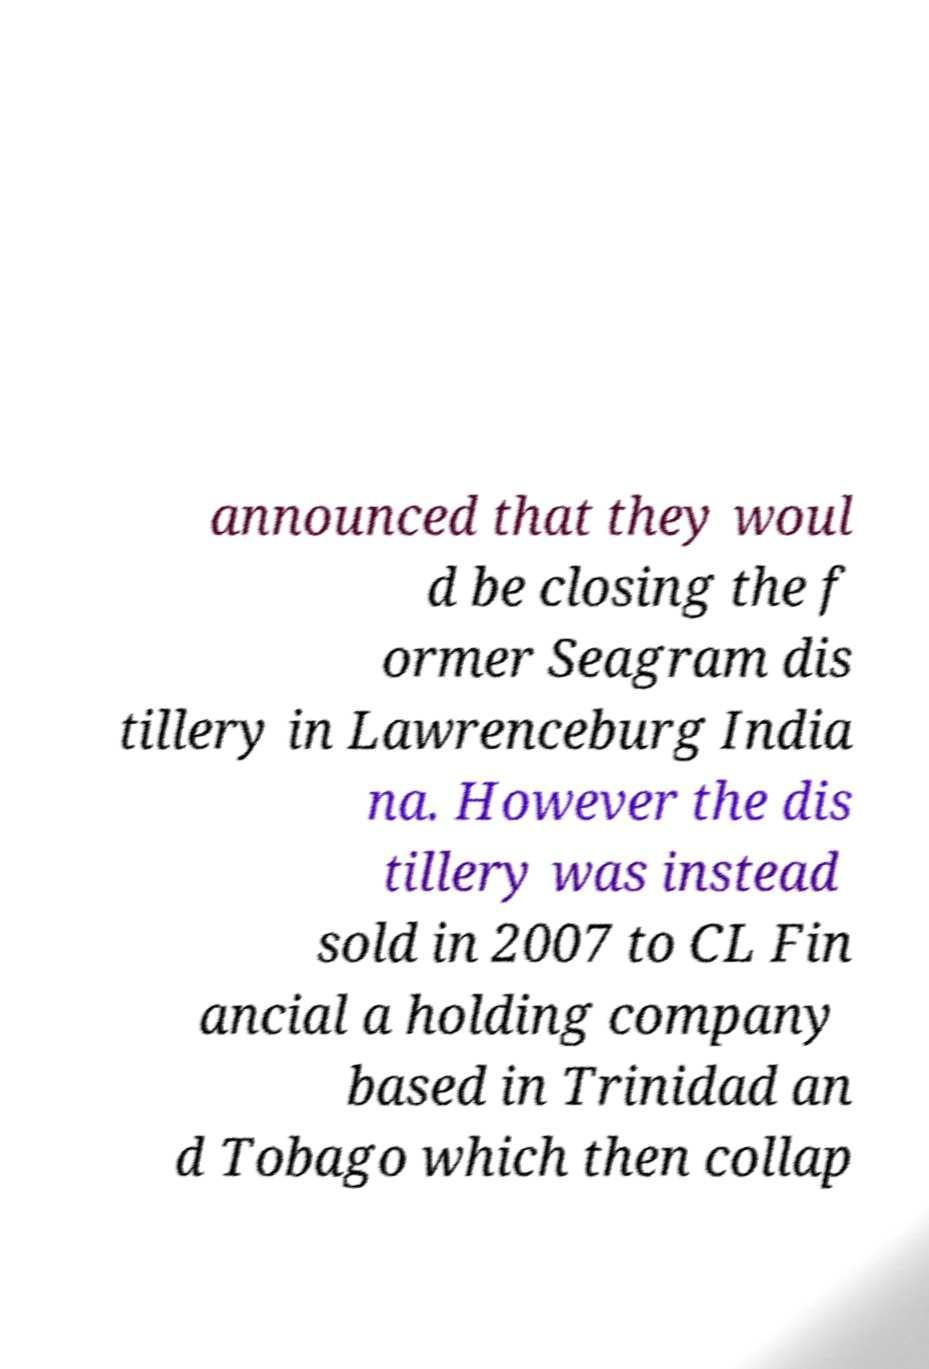I need the written content from this picture converted into text. Can you do that? announced that they woul d be closing the f ormer Seagram dis tillery in Lawrenceburg India na. However the dis tillery was instead sold in 2007 to CL Fin ancial a holding company based in Trinidad an d Tobago which then collap 